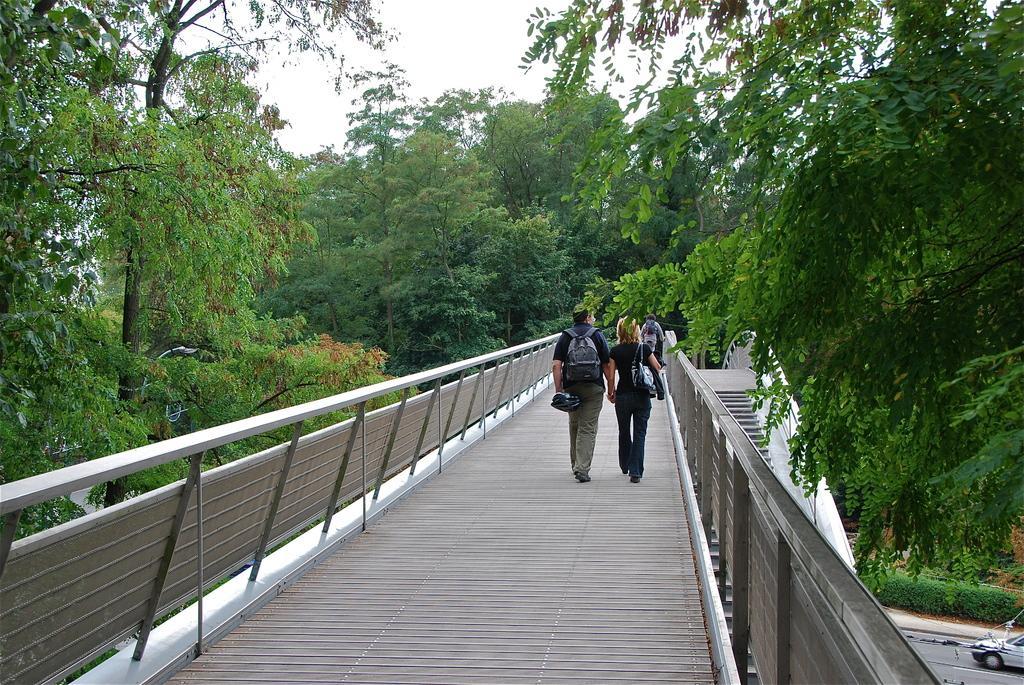What are the people in the image doing? There are people walking on the bridge in the image. What can be seen in the background of the image? There are trees in the background of the image. What is visible at the top of the image? The sky is visible at the top of the image. What is located at the bottom of the image? There is a road at the bottom of the image. What type of vehicle is on the road? There is a car on the road. What is the level of debt for the people walking on the bridge in the image? There is no information about the people's debt in the image. How low is the bridge in the image? The height of the bridge is not mentioned in the image, so it cannot be determined. 